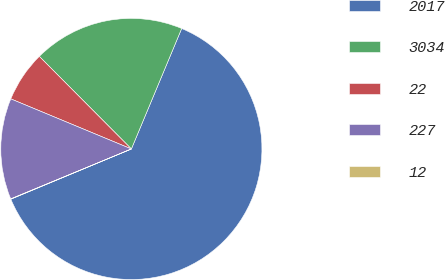Convert chart to OTSL. <chart><loc_0><loc_0><loc_500><loc_500><pie_chart><fcel>2017<fcel>3034<fcel>22<fcel>227<fcel>12<nl><fcel>62.42%<fcel>18.75%<fcel>6.28%<fcel>12.51%<fcel>0.04%<nl></chart> 